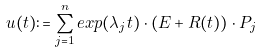Convert formula to latex. <formula><loc_0><loc_0><loc_500><loc_500>u ( t ) \colon = \sum ^ { n } _ { j = 1 } e x p ( \lambda _ { j } t ) \cdot ( E + R ( t ) ) \cdot P _ { j }</formula> 